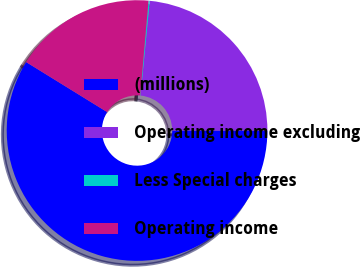Convert chart to OTSL. <chart><loc_0><loc_0><loc_500><loc_500><pie_chart><fcel>(millions)<fcel>Operating income excluding<fcel>Less Special charges<fcel>Operating income<nl><fcel>58.78%<fcel>23.46%<fcel>0.15%<fcel>17.6%<nl></chart> 